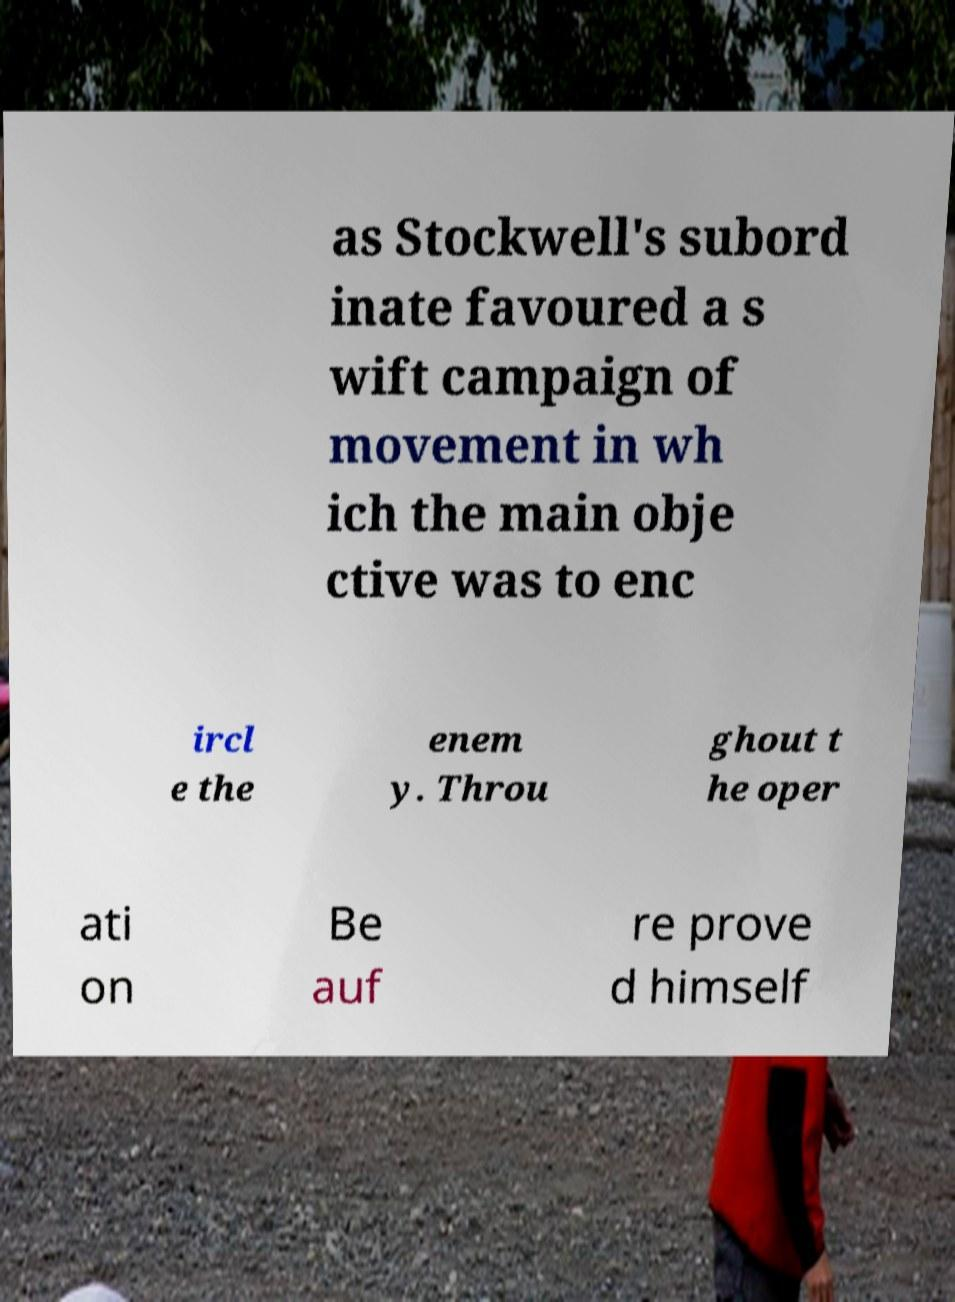Can you read and provide the text displayed in the image?This photo seems to have some interesting text. Can you extract and type it out for me? as Stockwell's subord inate favoured a s wift campaign of movement in wh ich the main obje ctive was to enc ircl e the enem y. Throu ghout t he oper ati on Be auf re prove d himself 